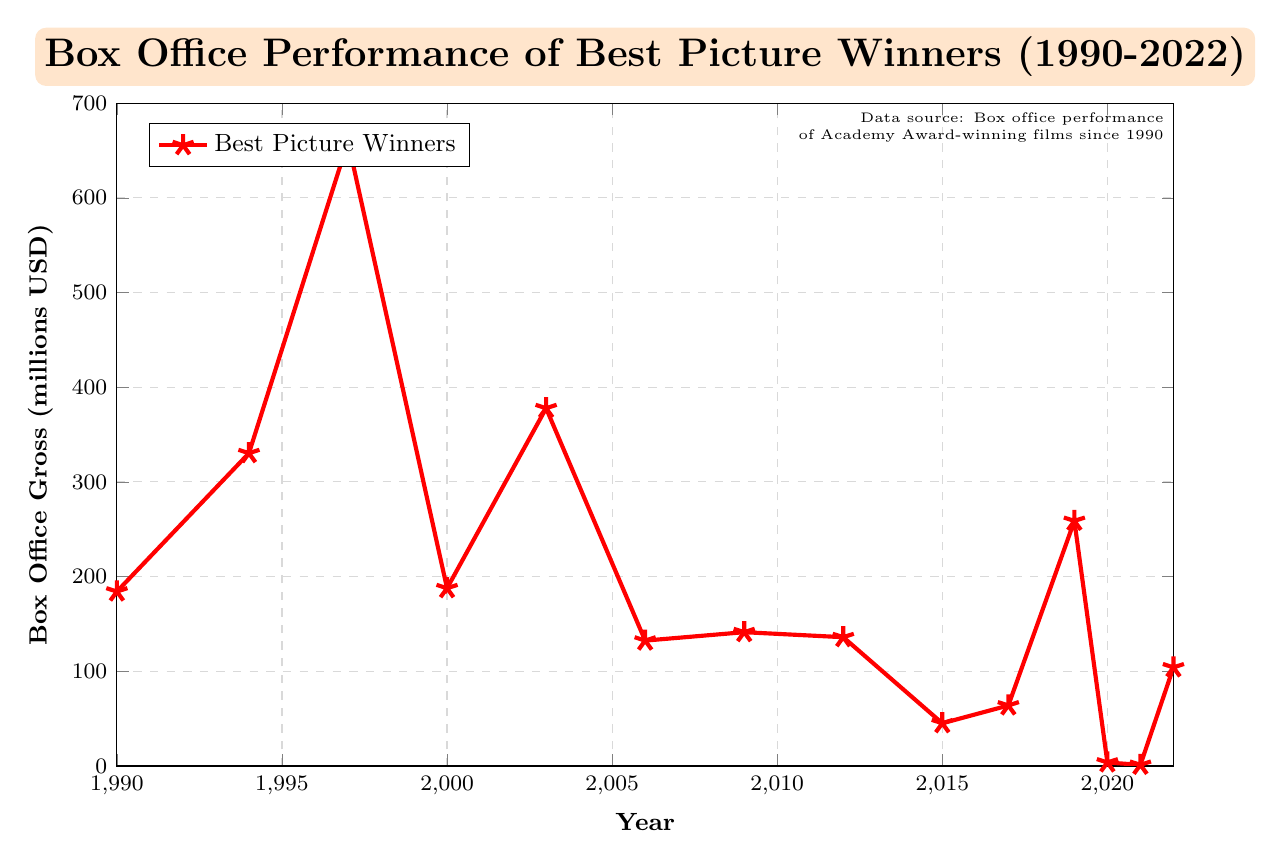Which Academy Award-winning film had the highest box office gross? By looking at the figure, we find the point that has the highest vertical position, corresponding to the year 1997 with the movie "Titanic".
Answer: Titanic What is the box office gross difference between "Forrest Gump" and "Everything Everywhere All at Once"? From the chart, "Forrest Gump" has a box office gross of 330.3 million USD, and "Everything Everywhere All at Once" has 104.1 million USD. The difference is 330.3 - 104.1 = 226.2 million USD.
Answer: 226.2 million USD Which year saw the lowest box office gross for the Best Picture Winner, and what movie was it? The lowest point on the chart corresponds to the year 2021 with a box office gross of 1.2 million USD for the movie "CODA".
Answer: 2021, CODA Between 1990 and 2000, which Best Picture winner had the smallest box office gross? By analyzing the data points between 1990 and 2000, the movie "Dances with Wolves" (1990) grossed 184.2 million USD, "Forrest Gump" (1994) grossed 330.3 million USD, "Titanic" (1997) grossed 659.4 million USD, and "Gladiator" (2000) grossed 187.7 million USD. The smallest box office gross in this range is "Dances with Wolves".
Answer: Dances with Wolves How many Best Picture winners since 1990 have grossed over 300 million USD at the box office? The relevant data points are from the years 1994 (Forrest Gump, 330.3 million USD), 1997 (Titanic, 659.4 million USD), and 2003 (The Lord of the Rings: The Return of the King, 377.8 million USD), making a total of three films.
Answer: 3 What is the average box office gross of the Best Picture winners for the years 2015, 2017, and 2019? The box office figures for the years 2015, 2017, and 2019 are 45.1 million USD, 63.9 million USD, and 258.8 million USD, respectively. Their sum is 45.1 + 63.9 + 258.8 = 367.8 million USD. The average is 367.8 / 3 = 122.6 million USD.
Answer: 122.6 million USD Which movie had a larger box office gross: "The Departed" or "Argo"? From the figure, "The Departed" (2006) grossed 132.4 million USD and "Argo" (2012) grossed 136.0 million USD. Thus, "Argo" had a larger box office gross.
Answer: Argo Is there any Best Picture winner between 2010 and 2020 with a box office gross similar to "Gladiator" (2000)? "Gladiator" had a box office gross of 187.7 million USD. Between 2010 and 2020, "Parasite" (2019) grossed 258.8 million USD, which is not very close but relatively higher compared to others in that range. No movie in that period has a box office gross close to the exact figure of "Gladiator".
Answer: No 